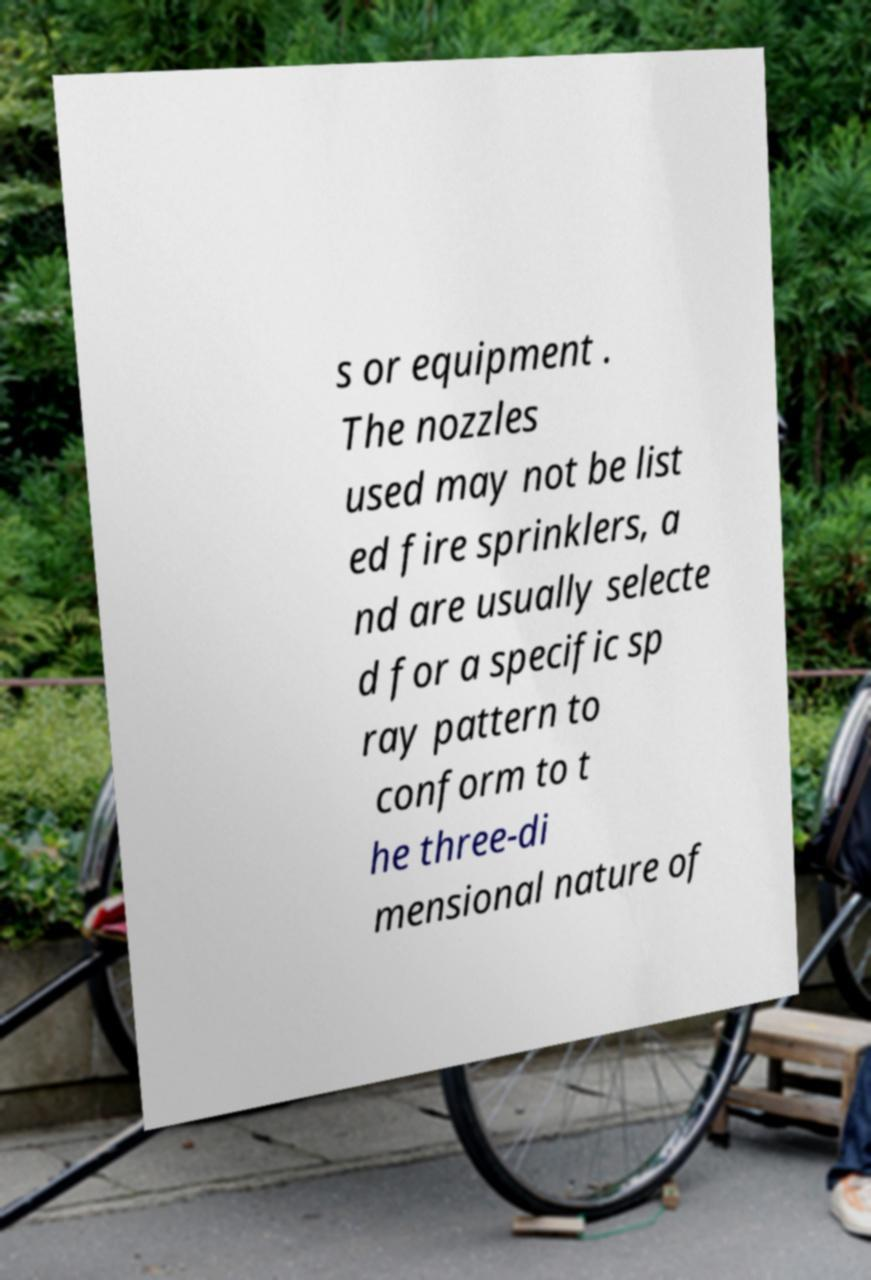Can you accurately transcribe the text from the provided image for me? s or equipment . The nozzles used may not be list ed fire sprinklers, a nd are usually selecte d for a specific sp ray pattern to conform to t he three-di mensional nature of 